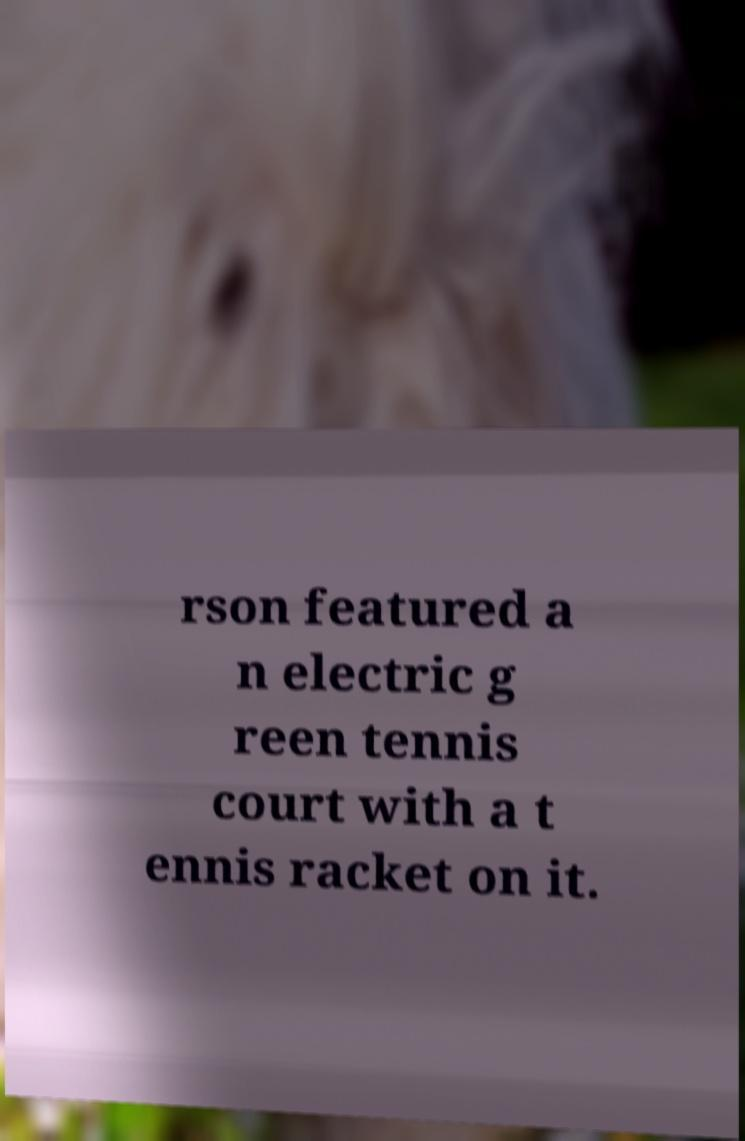Can you accurately transcribe the text from the provided image for me? rson featured a n electric g reen tennis court with a t ennis racket on it. 